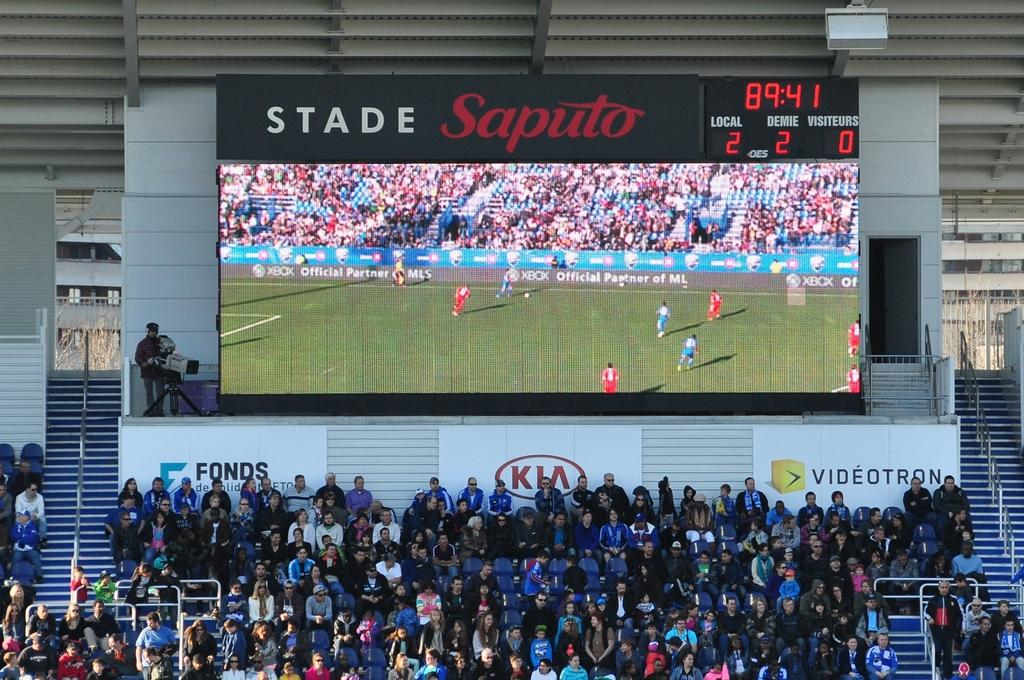<image>
Describe the image concisely. A big screen at Stade Saputo over bleachers with people. 